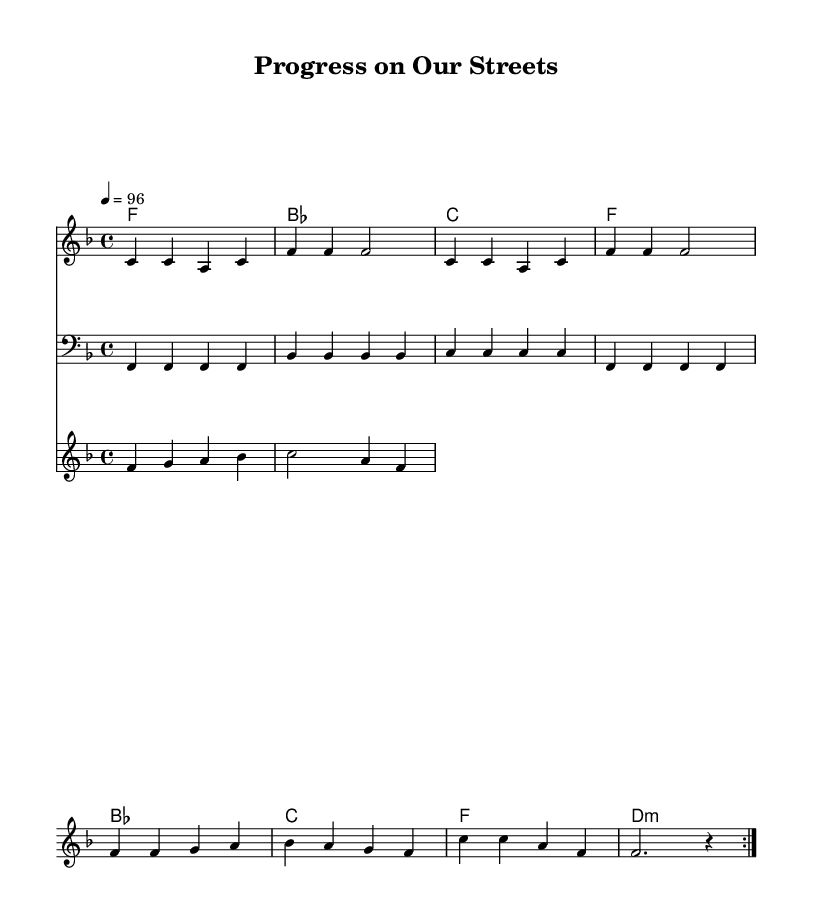What is the key signature of this music? The key signature indicates that the music is in F major, which has one flat (B flat). This can be observed at the beginning of the sheet music where the key signature is notated.
Answer: F major What is the time signature of this piece? The time signature is indicated after the key signature, which shows that the piece is in 4/4 time. This means there are four beats in each measure and a quarter note receives one beat.
Answer: 4/4 What is the tempo marking for this music? The tempo marking appears at the top of the sheet music, indicating it is set at 96 beats per minute, which dictates the speed of the performance.
Answer: 96 How many measures are there in the melody section? Counting the measures in the melody staff, there are a total of 8 measures as indicated by the grouping and structure of the melody notes.
Answer: 8 What type of chord is played in the first measure? The first measure indicates an F major chord, which can be determined by the harmonic notation and the root of the chord indicated.
Answer: F major What rhythmic feel is most prominent in this soul piece? The piece has a strong backbeat typical of rhythm and blues, noted by the emphasis on the 2nd and 4th beats in the time signature. The bass line and melody support this rhythmic feel.
Answer: Backbeat Which instrument is playing the horn riff? The horn riff is indicated in a separate staff specifically marked for horns, which is a common section in rhythm and blues arrangements emphasizing brass instruments.
Answer: Horns 